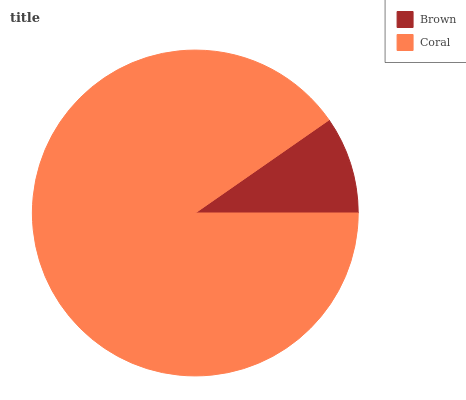Is Brown the minimum?
Answer yes or no. Yes. Is Coral the maximum?
Answer yes or no. Yes. Is Coral the minimum?
Answer yes or no. No. Is Coral greater than Brown?
Answer yes or no. Yes. Is Brown less than Coral?
Answer yes or no. Yes. Is Brown greater than Coral?
Answer yes or no. No. Is Coral less than Brown?
Answer yes or no. No. Is Coral the high median?
Answer yes or no. Yes. Is Brown the low median?
Answer yes or no. Yes. Is Brown the high median?
Answer yes or no. No. Is Coral the low median?
Answer yes or no. No. 